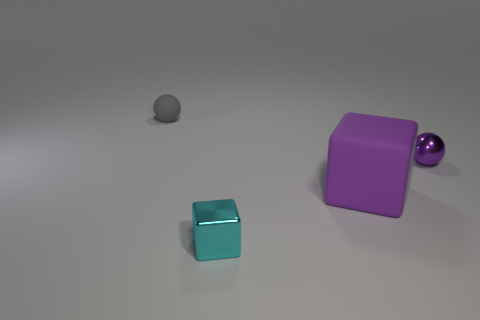What number of rubber things are both on the right side of the small gray matte object and on the left side of the cyan metal cube?
Provide a short and direct response. 0. There is a thing that is behind the tiny purple object; what is its shape?
Offer a terse response. Sphere. How many cyan objects are the same material as the purple ball?
Give a very brief answer. 1. There is a large rubber thing; is its shape the same as the metal object behind the big rubber object?
Ensure brevity in your answer.  No. Is there a purple matte block to the left of the shiny object to the right of the small object that is in front of the tiny purple ball?
Your response must be concise. Yes. What size is the sphere that is on the left side of the purple metallic ball?
Offer a terse response. Small. What material is the gray object that is the same size as the shiny block?
Keep it short and to the point. Rubber. Is the small matte object the same shape as the small purple metallic thing?
Offer a very short reply. Yes. How many objects are either red matte blocks or small shiny things that are left of the purple metal ball?
Make the answer very short. 1. There is a small ball that is the same color as the large matte block; what material is it?
Offer a terse response. Metal. 